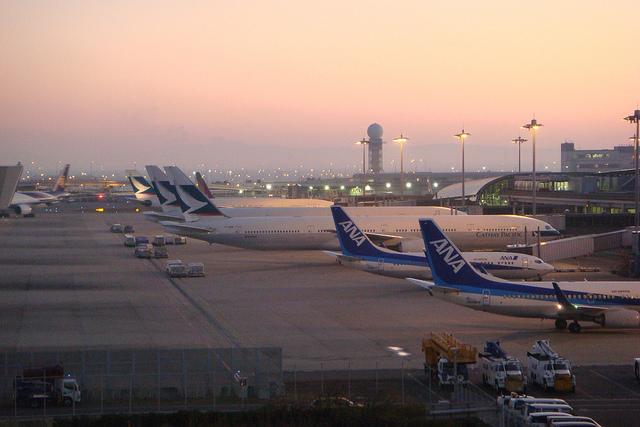Is there a fountain in the picture?
Quick response, please. No. Is it a cloudy day?
Be succinct. Yes. Are these boats?
Keep it brief. No. Where are the planes?
Write a very short answer. Airport. What does the big building appear to be?
Be succinct. Airport. How many planes are flying?
Write a very short answer. 0. Are there lights present?
Write a very short answer. Yes. What is cast?
Concise answer only. Sky. What color is the tail of the plane?
Concise answer only. Blue. Is the plane landing?
Short answer required. No. Are the parked planes F-18's?
Write a very short answer. No. Is this a marina?
Concise answer only. No. How many airplanes are at the gate?
Concise answer only. 5. 